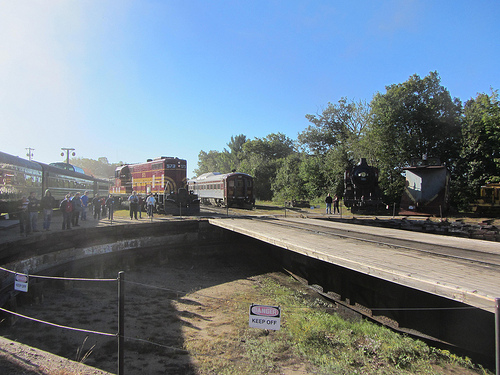Is the long train to the right or to the left of the people that are on the platform? The long train is to the right of the people who are standing on the platform. 